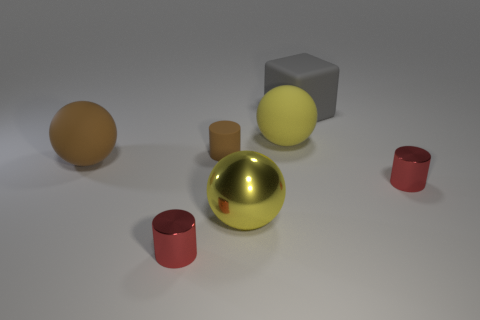There is a gray block; how many cylinders are in front of it?
Provide a succinct answer. 3. There is a tiny cylinder that is in front of the sphere that is in front of the big brown object; what is its material?
Make the answer very short. Metal. Is there a big matte thing that has the same color as the large metal ball?
Give a very brief answer. Yes. What size is the brown cylinder that is the same material as the block?
Provide a short and direct response. Small. Is there any other thing that is the same color as the tiny matte thing?
Make the answer very short. Yes. What is the color of the small metallic object left of the rubber block?
Make the answer very short. Red. There is a tiny object that is in front of the small shiny object that is to the right of the yellow metal thing; is there a small red thing that is on the left side of it?
Give a very brief answer. No. Are there more matte balls to the right of the brown ball than big purple rubber balls?
Provide a short and direct response. Yes. There is a shiny object that is behind the yellow metal sphere; is its shape the same as the gray rubber thing?
Keep it short and to the point. No. What number of things are small blue metallic cylinders or small red shiny things behind the metal ball?
Provide a short and direct response. 1. 